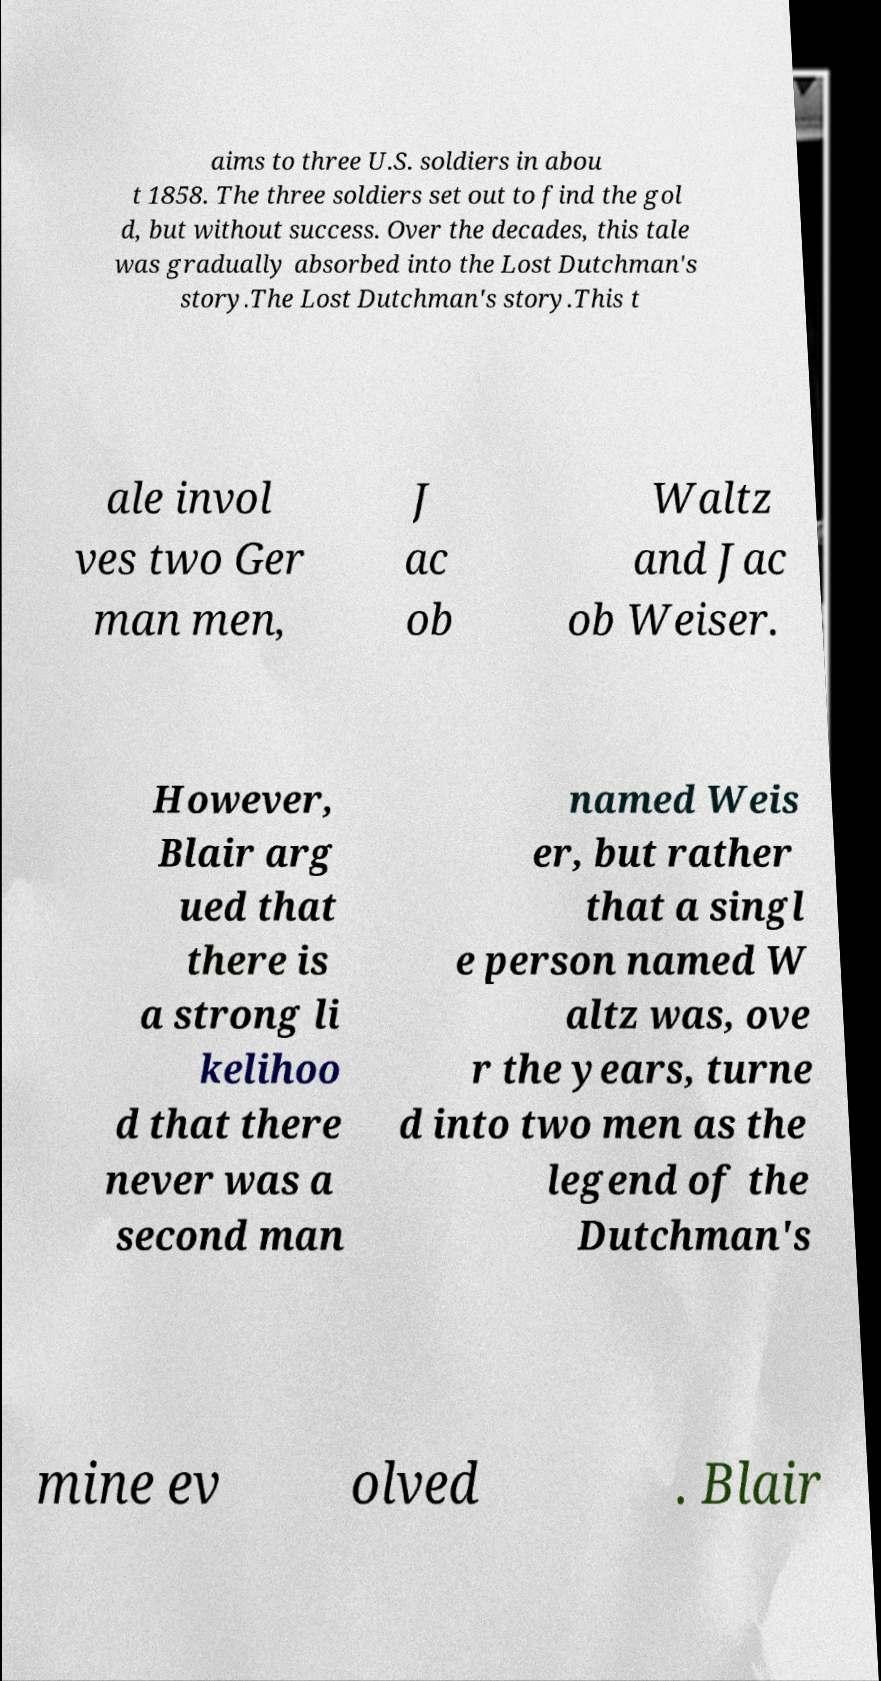There's text embedded in this image that I need extracted. Can you transcribe it verbatim? aims to three U.S. soldiers in abou t 1858. The three soldiers set out to find the gol d, but without success. Over the decades, this tale was gradually absorbed into the Lost Dutchman's story.The Lost Dutchman's story.This t ale invol ves two Ger man men, J ac ob Waltz and Jac ob Weiser. However, Blair arg ued that there is a strong li kelihoo d that there never was a second man named Weis er, but rather that a singl e person named W altz was, ove r the years, turne d into two men as the legend of the Dutchman's mine ev olved . Blair 